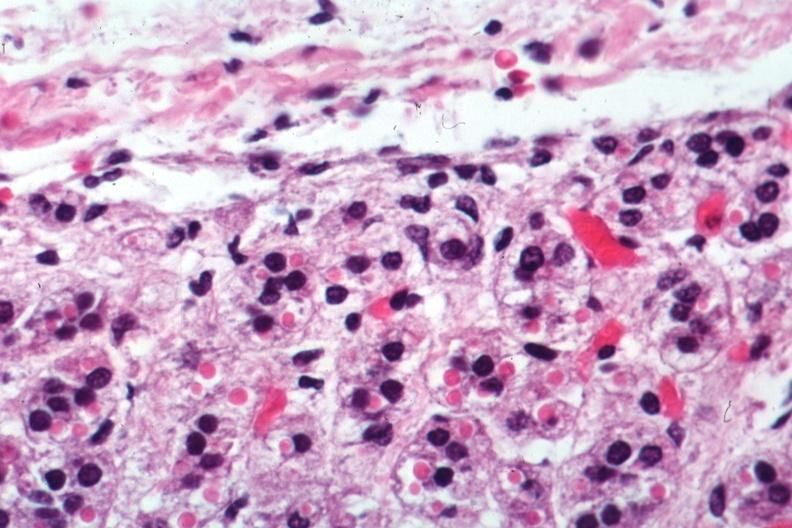what is present?
Answer the question using a single word or phrase. Adrenal 